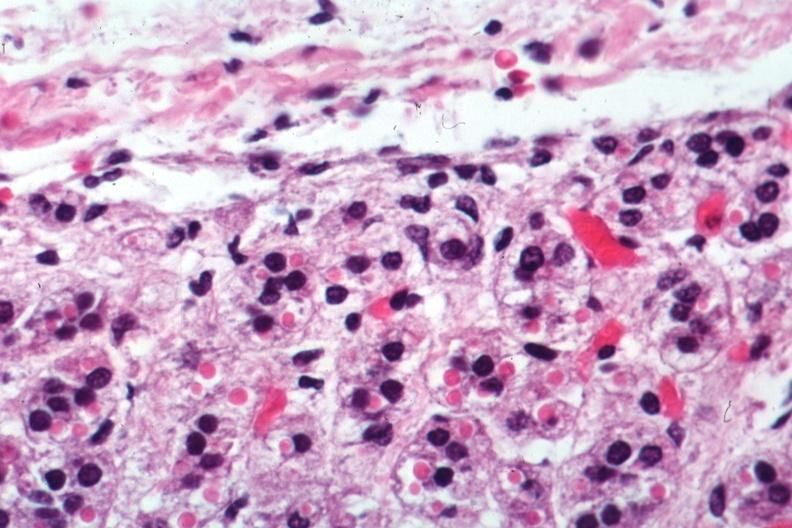what is present?
Answer the question using a single word or phrase. Adrenal 